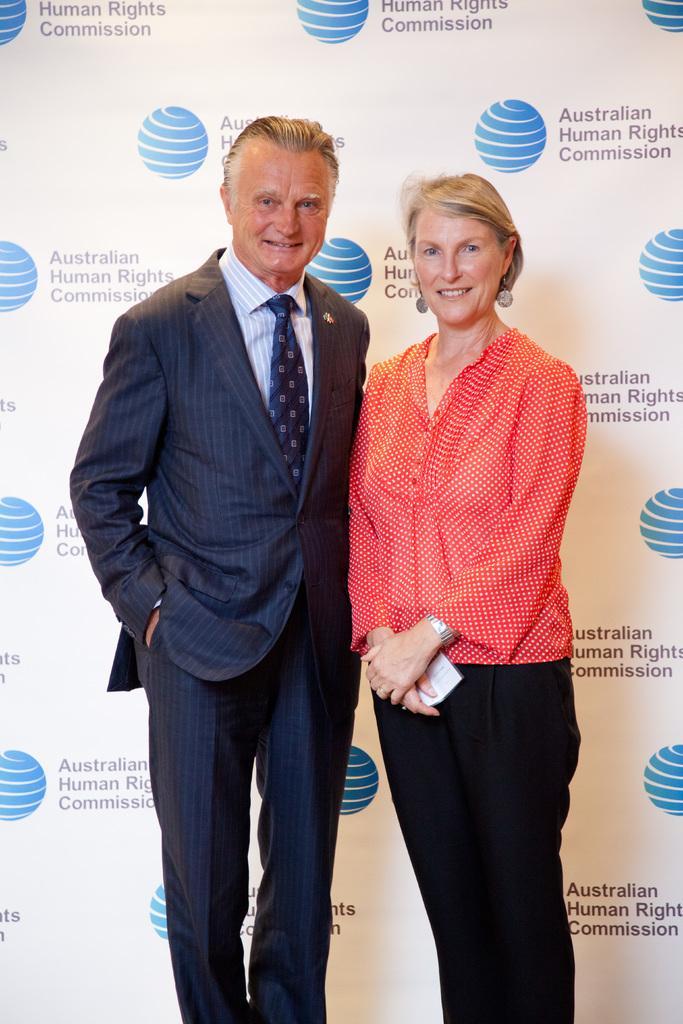Can you describe this image briefly? In the image there are two people standing and posing for the photo and behind them there is a banner with the logos of some organization. 